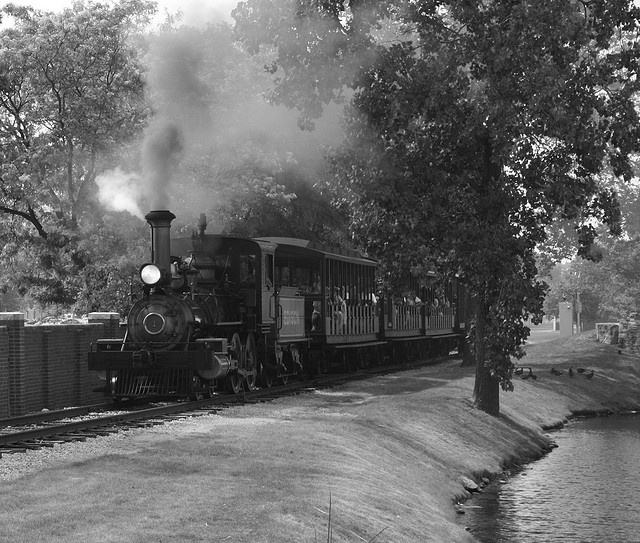Describe the objects in this image and their specific colors. I can see train in white, black, gray, darkgray, and lightgray tones, bird in black, gray, darkgray, and white tones, people in black, gray, and white tones, people in gray, black, and white tones, and bird in gray, black, and white tones in this image. 